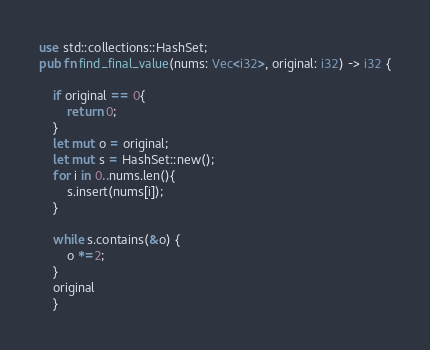Convert code to text. <code><loc_0><loc_0><loc_500><loc_500><_Rust_>
use std::collections::HashSet;
pub fn find_final_value(nums: Vec<i32>, original: i32) -> i32 {
    
    if original == 0{
        return 0;
    }
    let mut o = original;
    let mut s = HashSet::new();   
    for i in 0..nums.len(){
        s.insert(nums[i]);
    }
    
    while s.contains(&o) {
        o *=2;
    }
    original
    }</code> 